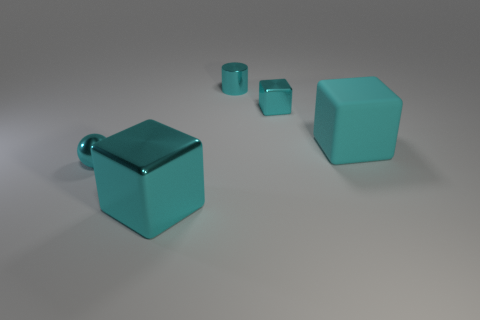How many things are either big cyan rubber objects or metallic cylinders?
Your answer should be very brief. 2. What number of shiny cylinders are the same size as the cyan shiny ball?
Your answer should be very brief. 1. What is the shape of the small metallic thing that is in front of the big cyan thing behind the large shiny cube?
Ensure brevity in your answer.  Sphere. Are there fewer big brown balls than large cyan blocks?
Provide a short and direct response. Yes. What is the color of the tiny metal ball that is left of the cyan matte block?
Offer a very short reply. Cyan. The tiny object that is in front of the metal cylinder and on the left side of the tiny cyan shiny block is made of what material?
Provide a short and direct response. Metal. The big cyan thing that is made of the same material as the cylinder is what shape?
Ensure brevity in your answer.  Cube. There is a big cyan thing on the left side of the cyan rubber block; how many big things are on the right side of it?
Your answer should be compact. 1. How many cyan things are both right of the large metal object and left of the rubber thing?
Ensure brevity in your answer.  2. How many other things are the same material as the cyan ball?
Your response must be concise. 3. 